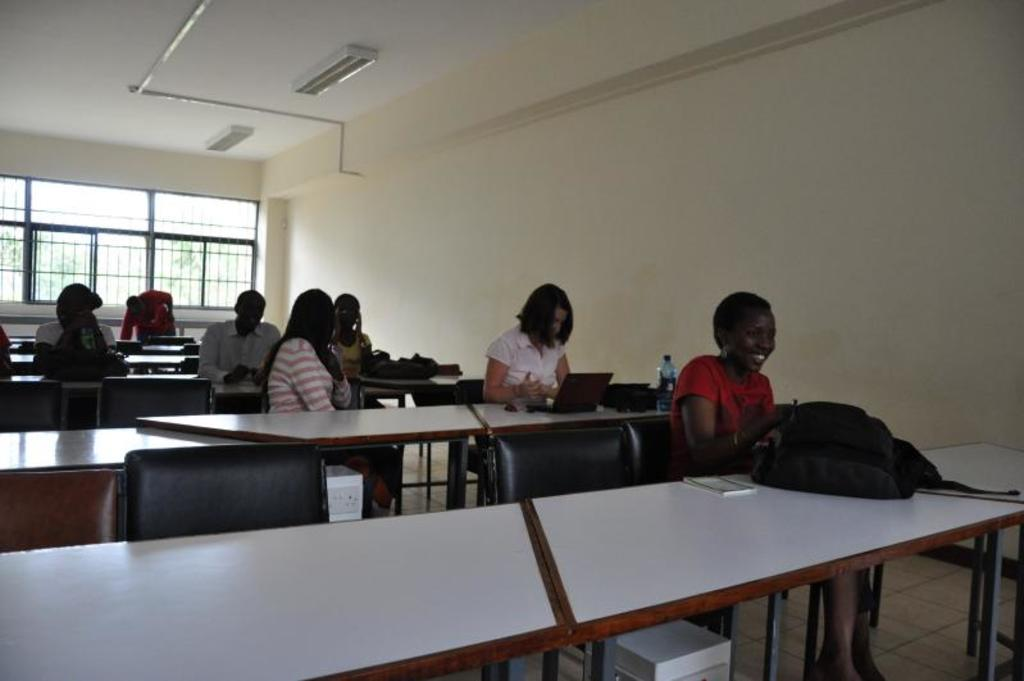How many people are in the image? There is a group of people in the image. What are the people doing in the image? The people are sitting in a chair. What is in front of the people? There is a table in front of the people. What can be seen in the background of the image? There is a window in the background of the image. What type of jelly is on the stomach of the person in the image? There is no jelly present in the image, and no one's stomach is visible. 